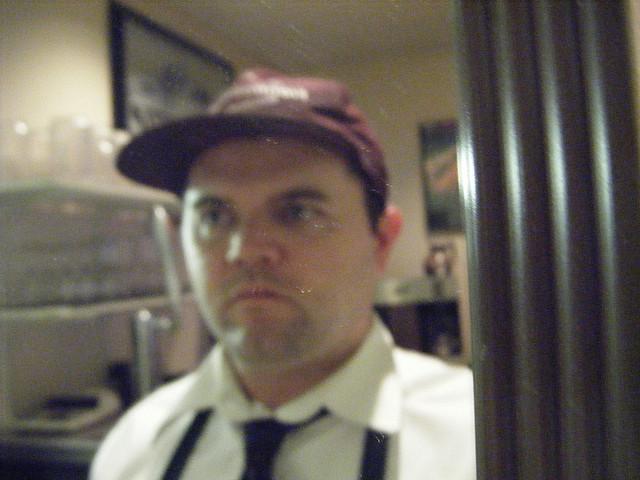How many pieces of pizza are cut?
Give a very brief answer. 0. 